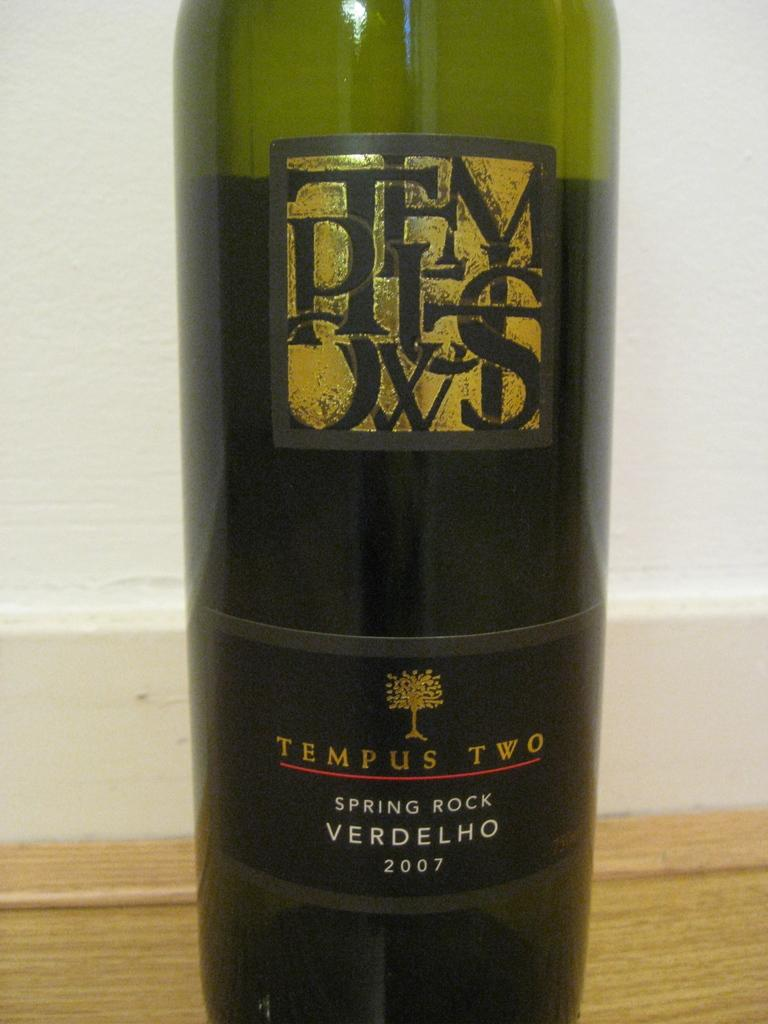What object is placed on the table in the image? There is a bottle on the table. How many bags can be seen in the image? There are no bags present in the image; it only features a bottle on the table. What type of cars can be seen driving by in the image? There are no cars visible in the image; it only features a bottle on the table. 